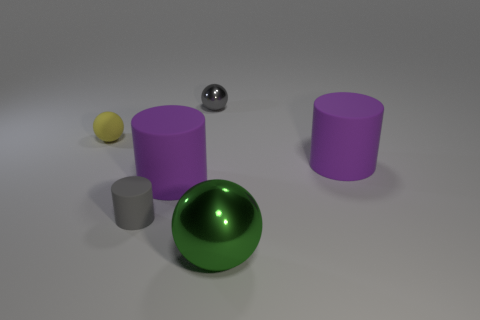Subtract all yellow blocks. How many purple cylinders are left? 2 Add 4 big rubber cylinders. How many objects exist? 10 Subtract 0 yellow cubes. How many objects are left? 6 Subtract all small rubber things. Subtract all small brown rubber cylinders. How many objects are left? 4 Add 4 small gray balls. How many small gray balls are left? 5 Add 3 rubber cylinders. How many rubber cylinders exist? 6 